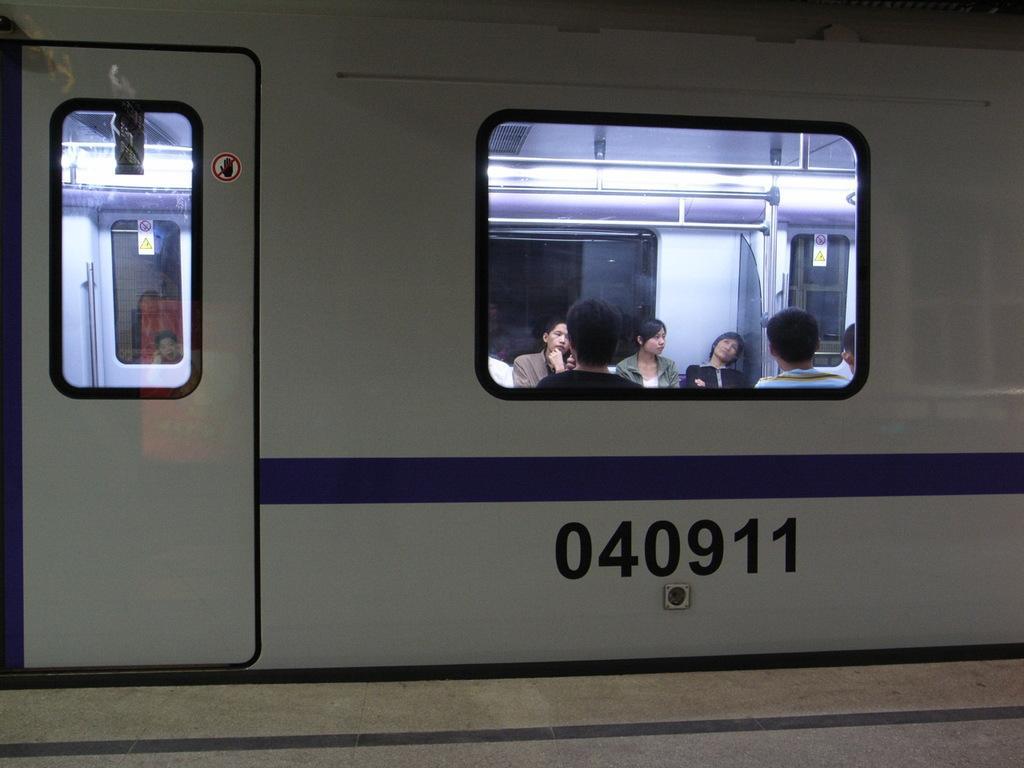Describe this image in one or two sentences. In this image we can see a train and a group of people present as we can see through the window glass. 